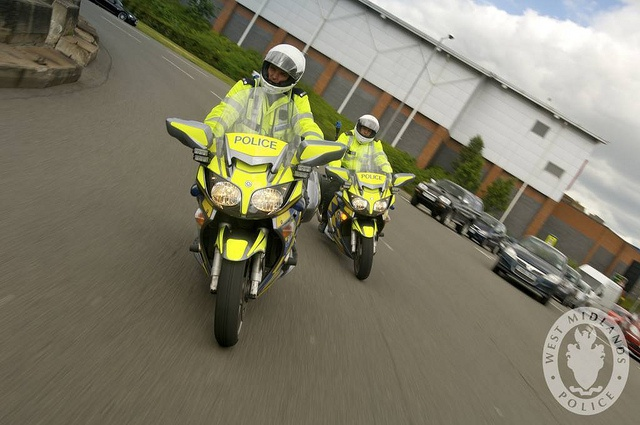Describe the objects in this image and their specific colors. I can see motorcycle in black, gray, yellow, and darkgreen tones, people in black, darkgray, olive, and khaki tones, motorcycle in black, khaki, darkgreen, and olive tones, car in black, gray, darkgray, and lightgray tones, and truck in black, gray, and darkgray tones in this image. 